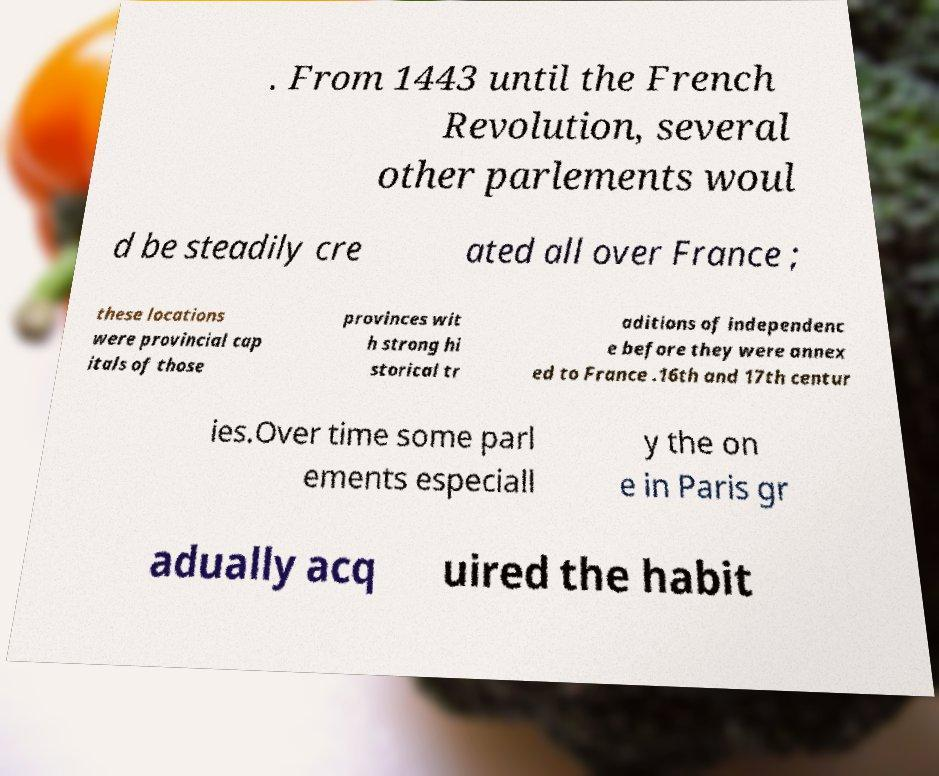What messages or text are displayed in this image? I need them in a readable, typed format. . From 1443 until the French Revolution, several other parlements woul d be steadily cre ated all over France ; these locations were provincial cap itals of those provinces wit h strong hi storical tr aditions of independenc e before they were annex ed to France .16th and 17th centur ies.Over time some parl ements especiall y the on e in Paris gr adually acq uired the habit 